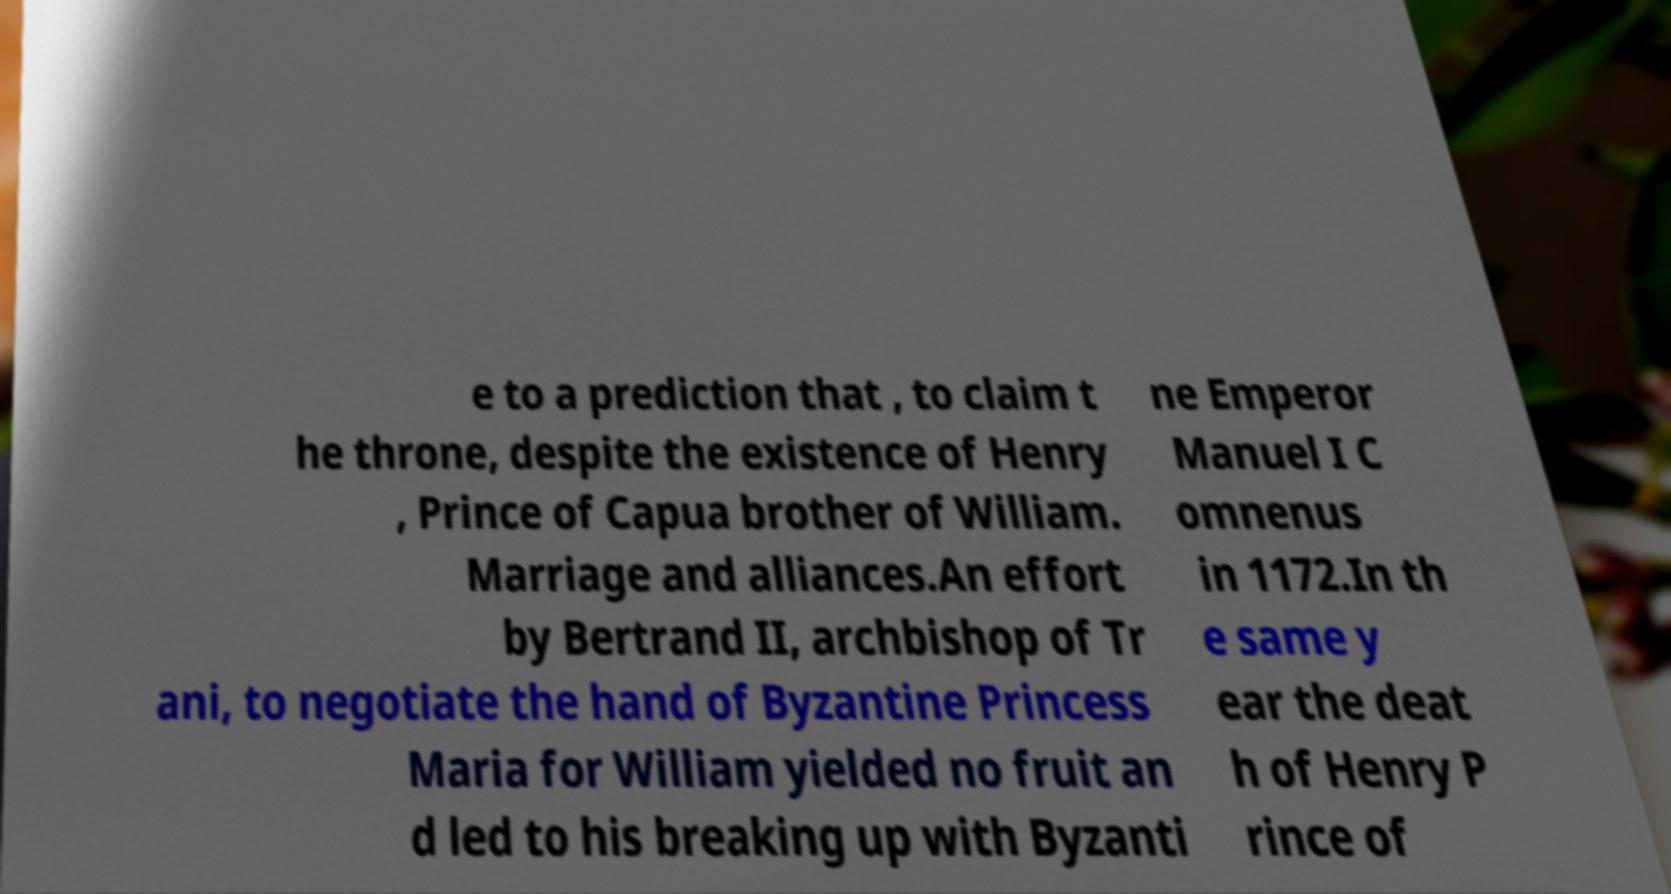Can you read and provide the text displayed in the image?This photo seems to have some interesting text. Can you extract and type it out for me? e to a prediction that , to claim t he throne, despite the existence of Henry , Prince of Capua brother of William. Marriage and alliances.An effort by Bertrand II, archbishop of Tr ani, to negotiate the hand of Byzantine Princess Maria for William yielded no fruit an d led to his breaking up with Byzanti ne Emperor Manuel I C omnenus in 1172.In th e same y ear the deat h of Henry P rince of 